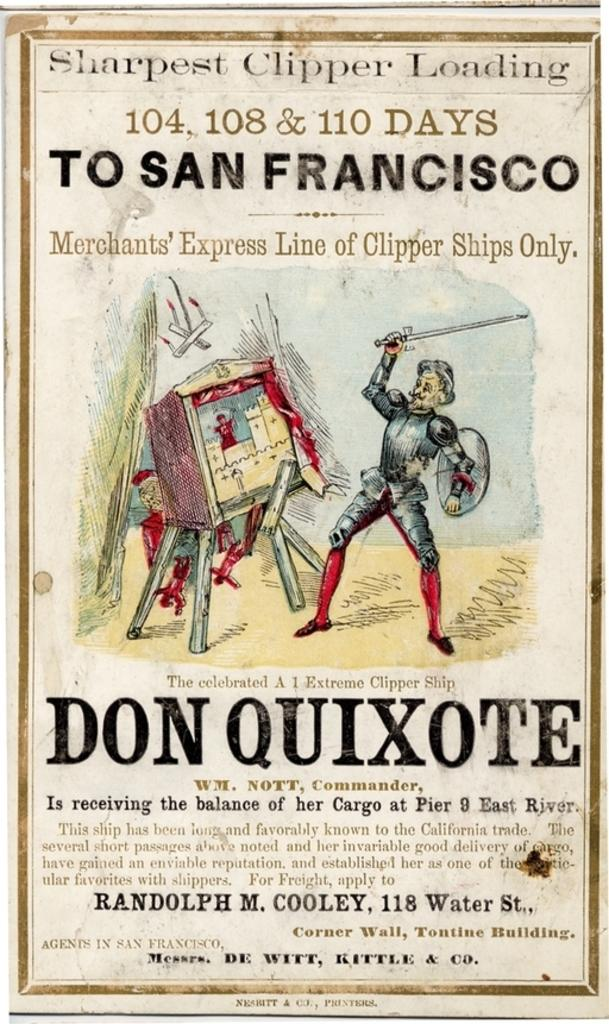<image>
Create a compact narrative representing the image presented. A poster for Don Quixote features an armored man with a sword. 